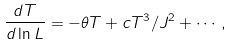<formula> <loc_0><loc_0><loc_500><loc_500>\frac { d T } { d \ln L } = - \theta T + c T ^ { 3 } / J ^ { 2 } + \cdots ,</formula> 